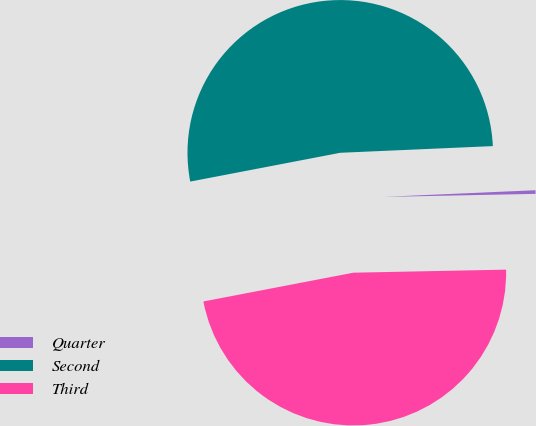Convert chart to OTSL. <chart><loc_0><loc_0><loc_500><loc_500><pie_chart><fcel>Quarter<fcel>Second<fcel>Third<nl><fcel>0.38%<fcel>52.32%<fcel>47.3%<nl></chart> 